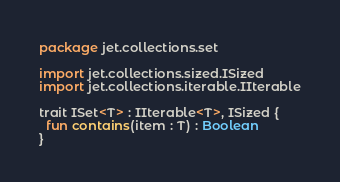<code> <loc_0><loc_0><loc_500><loc_500><_Kotlin_>package jet.collections.set

import jet.collections.sized.ISized
import jet.collections.iterable.IIterable

trait ISet<T> : IIterable<T>, ISized {
  fun contains(item : T) : Boolean
}
</code> 